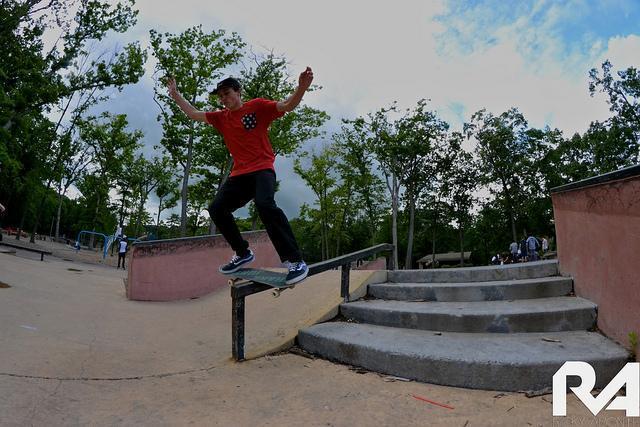How many orange cups are on the table?
Give a very brief answer. 0. 